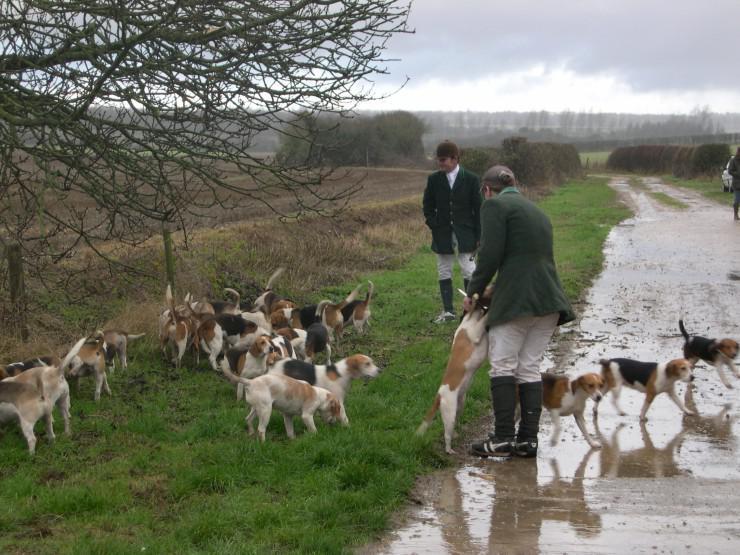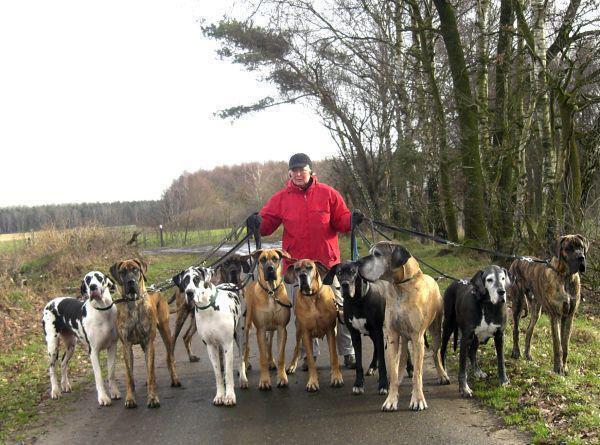The first image is the image on the left, the second image is the image on the right. For the images displayed, is the sentence "At least one horse is present with a group of hounds in one image." factually correct? Answer yes or no. No. The first image is the image on the left, the second image is the image on the right. Given the left and right images, does the statement "A horse is in a grassy area with a group of dogs." hold true? Answer yes or no. No. 